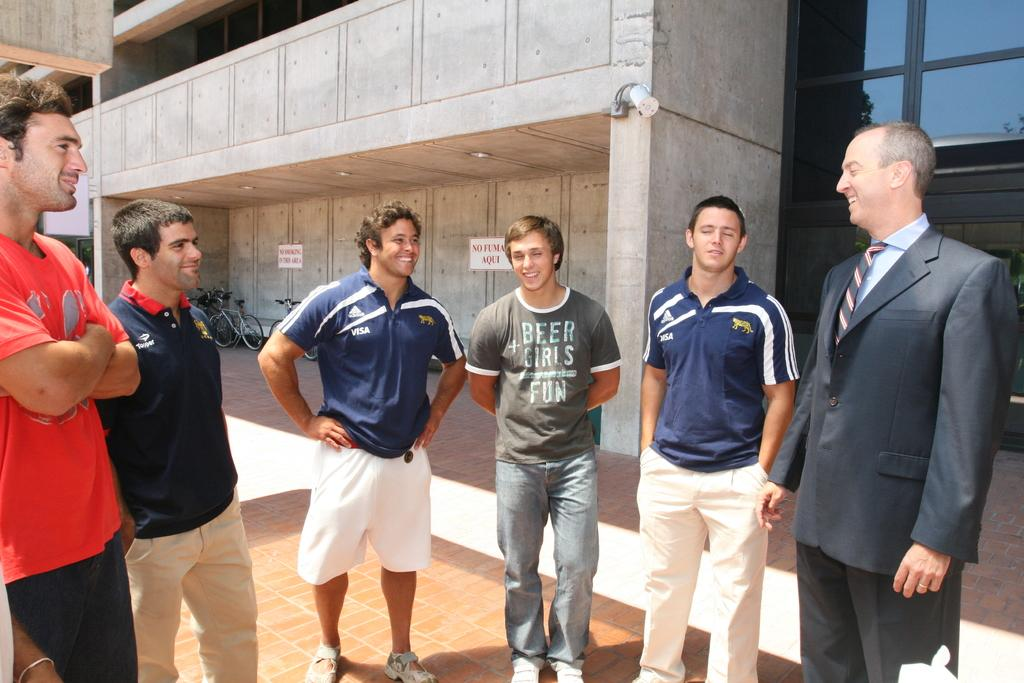What is happening in the image? There is a group of people standing in the image. What can be seen in the background of the image? There are bicycles and a building in the background of the image. Can you describe a specific feature on the right side of the image? There is a glass wall on the right side of the image. What type of gold object is visible on the slope in the image? There is no gold object or slope present in the image. 